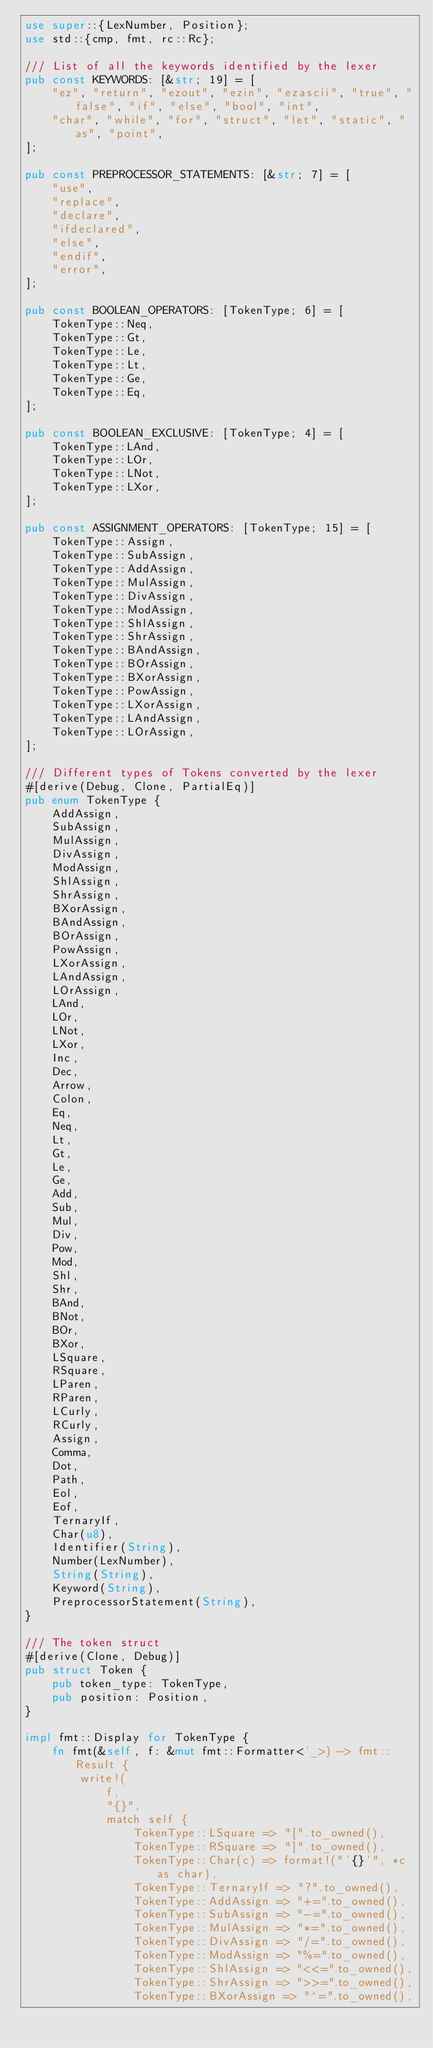<code> <loc_0><loc_0><loc_500><loc_500><_Rust_>use super::{LexNumber, Position};
use std::{cmp, fmt, rc::Rc};

/// List of all the keywords identified by the lexer
pub const KEYWORDS: [&str; 19] = [
    "ez", "return", "ezout", "ezin", "ezascii", "true", "false", "if", "else", "bool", "int",
    "char", "while", "for", "struct", "let", "static", "as", "point",
];

pub const PREPROCESSOR_STATEMENTS: [&str; 7] = [
    "use",
    "replace",
    "declare",
    "ifdeclared",
    "else",
    "endif",
    "error",
];

pub const BOOLEAN_OPERATORS: [TokenType; 6] = [
    TokenType::Neq,
    TokenType::Gt,
    TokenType::Le,
    TokenType::Lt,
    TokenType::Ge,
    TokenType::Eq,
];

pub const BOOLEAN_EXCLUSIVE: [TokenType; 4] = [
    TokenType::LAnd,
    TokenType::LOr,
    TokenType::LNot,
    TokenType::LXor,
];

pub const ASSIGNMENT_OPERATORS: [TokenType; 15] = [
    TokenType::Assign,
    TokenType::SubAssign,
    TokenType::AddAssign,
    TokenType::MulAssign,
    TokenType::DivAssign,
    TokenType::ModAssign,
    TokenType::ShlAssign,
    TokenType::ShrAssign,
    TokenType::BAndAssign,
    TokenType::BOrAssign,
    TokenType::BXorAssign,
    TokenType::PowAssign,
    TokenType::LXorAssign,
    TokenType::LAndAssign,
    TokenType::LOrAssign,
];

/// Different types of Tokens converted by the lexer
#[derive(Debug, Clone, PartialEq)]
pub enum TokenType {
    AddAssign,
    SubAssign,
    MulAssign,
    DivAssign,
    ModAssign,
    ShlAssign,
    ShrAssign,
    BXorAssign,
    BAndAssign,
    BOrAssign,
    PowAssign,
    LXorAssign,
    LAndAssign,
    LOrAssign,
    LAnd,
    LOr,
    LNot,
    LXor,
    Inc,
    Dec,
    Arrow,
    Colon,
    Eq,
    Neq,
    Lt,
    Gt,
    Le,
    Ge,
    Add,
    Sub,
    Mul,
    Div,
    Pow,
    Mod,
    Shl,
    Shr,
    BAnd,
    BNot,
    BOr,
    BXor,
    LSquare,
    RSquare,
    LParen,
    RParen,
    LCurly,
    RCurly,
    Assign,
    Comma,
    Dot,
    Path,
    Eol,
    Eof,
    TernaryIf,
    Char(u8),
    Identifier(String),
    Number(LexNumber),
    String(String),
    Keyword(String),
    PreprocessorStatement(String),
}

/// The token struct
#[derive(Clone, Debug)]
pub struct Token {
    pub token_type: TokenType,
    pub position: Position,
}

impl fmt::Display for TokenType {
    fn fmt(&self, f: &mut fmt::Formatter<'_>) -> fmt::Result {
        write!(
            f,
            "{}",
            match self {
                TokenType::LSquare => "[".to_owned(),
                TokenType::RSquare => "]".to_owned(),
                TokenType::Char(c) => format!("'{}'", *c as char),
                TokenType::TernaryIf => "?".to_owned(),
                TokenType::AddAssign => "+=".to_owned(),
                TokenType::SubAssign => "-=".to_owned(),
                TokenType::MulAssign => "*=".to_owned(),
                TokenType::DivAssign => "/=".to_owned(),
                TokenType::ModAssign => "%=".to_owned(),
                TokenType::ShlAssign => "<<=".to_owned(),
                TokenType::ShrAssign => ">>=".to_owned(),
                TokenType::BXorAssign => "^=".to_owned(),</code> 